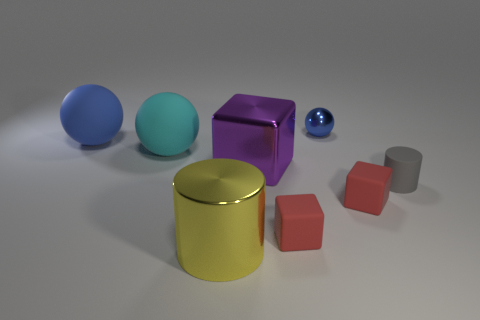What is the small blue sphere made of?
Offer a very short reply. Metal. Does the blue thing that is to the left of the big yellow thing have the same material as the small gray cylinder?
Make the answer very short. Yes. Is the number of tiny blue things in front of the large blue ball less than the number of big rubber spheres?
Make the answer very short. Yes. The other metallic object that is the same size as the yellow object is what color?
Make the answer very short. Purple. How many other things have the same shape as the purple metallic object?
Give a very brief answer. 2. What is the color of the big metallic block to the right of the large metal cylinder?
Provide a short and direct response. Purple. What number of metal objects are either big yellow cylinders or large purple things?
Ensure brevity in your answer.  2. What shape is the thing that is the same color as the tiny shiny ball?
Offer a very short reply. Sphere. How many yellow metallic things are the same size as the blue shiny sphere?
Your response must be concise. 0. The sphere that is on the left side of the purple cube and to the right of the large blue matte thing is what color?
Provide a short and direct response. Cyan. 